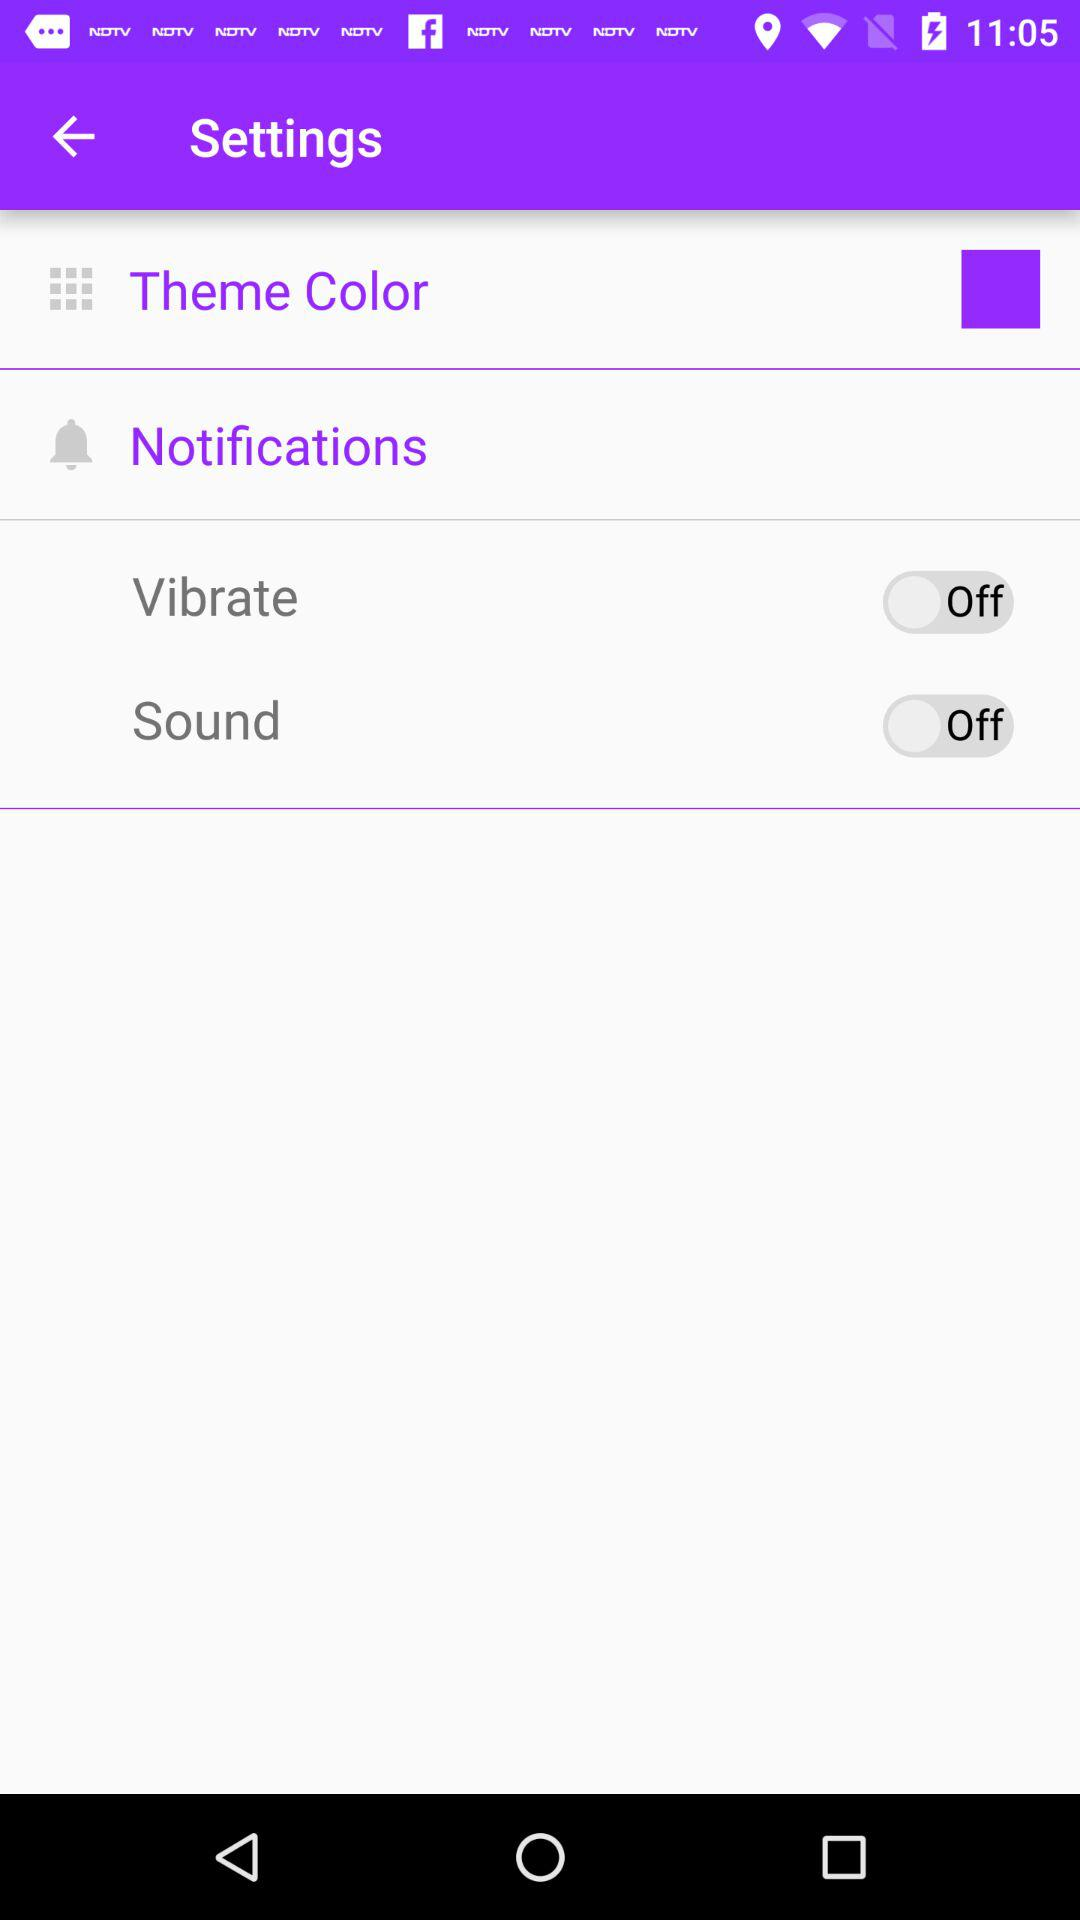What is the status of "Sound"? The status of "Sound" is "off". 